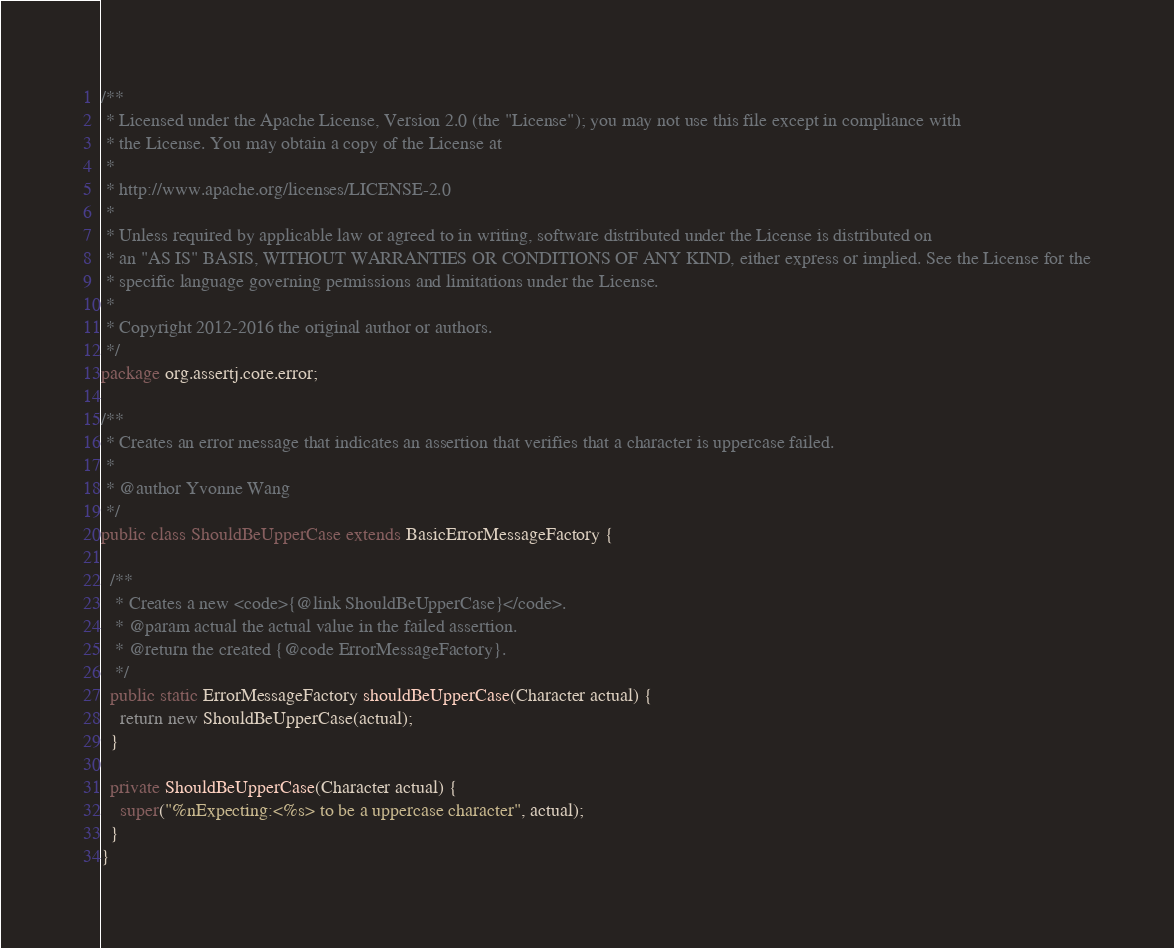Convert code to text. <code><loc_0><loc_0><loc_500><loc_500><_Java_>/**
 * Licensed under the Apache License, Version 2.0 (the "License"); you may not use this file except in compliance with
 * the License. You may obtain a copy of the License at
 *
 * http://www.apache.org/licenses/LICENSE-2.0
 *
 * Unless required by applicable law or agreed to in writing, software distributed under the License is distributed on
 * an "AS IS" BASIS, WITHOUT WARRANTIES OR CONDITIONS OF ANY KIND, either express or implied. See the License for the
 * specific language governing permissions and limitations under the License.
 *
 * Copyright 2012-2016 the original author or authors.
 */
package org.assertj.core.error;

/**
 * Creates an error message that indicates an assertion that verifies that a character is uppercase failed.
 * 
 * @author Yvonne Wang
 */
public class ShouldBeUpperCase extends BasicErrorMessageFactory {

  /**
   * Creates a new <code>{@link ShouldBeUpperCase}</code>.
   * @param actual the actual value in the failed assertion.
   * @return the created {@code ErrorMessageFactory}.
   */
  public static ErrorMessageFactory shouldBeUpperCase(Character actual) {
    return new ShouldBeUpperCase(actual);
  }

  private ShouldBeUpperCase(Character actual) {
    super("%nExpecting:<%s> to be a uppercase character", actual);
  }
}
</code> 